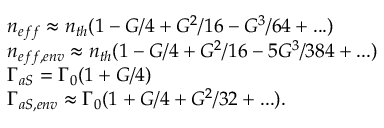<formula> <loc_0><loc_0><loc_500><loc_500>\begin{array} { r l } & { \, n _ { e f f } \approx n _ { t h } ( 1 - G / 4 + G ^ { 2 } / 1 6 - G ^ { 3 } / 6 4 + \dots ) } \\ & { \, n _ { e f f , e n v } \approx n _ { t h } ( 1 - G / 4 + G ^ { 2 } / 1 6 - 5 G ^ { 3 } / 3 8 4 + \dots ) } \\ & { \, \Gamma _ { a S } = \Gamma _ { 0 } ( 1 + G / 4 ) } \\ & { \, \Gamma _ { a S , e n v } \approx \Gamma _ { 0 } ( 1 + G / 4 + G ^ { 2 } / 3 2 + \dots ) . } \end{array}</formula> 